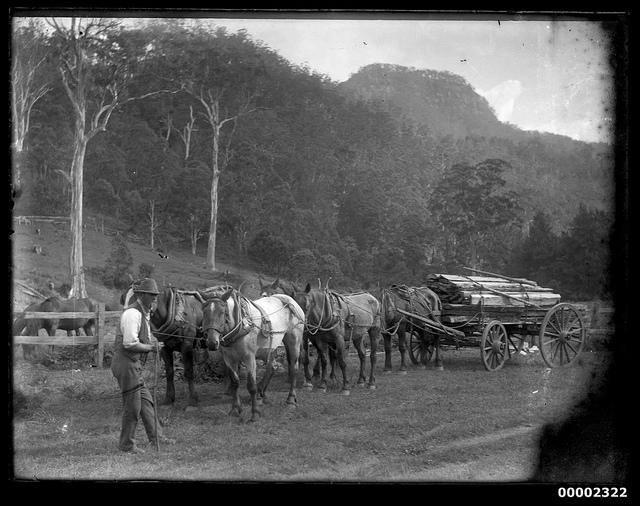What is the horse pulling?
Concise answer only. Wagon. What is the man hauling in the wagon?
Quick response, please. Logs. What is the man wearing over his shirt?
Answer briefly. Vest. What language is this photo captioned with?
Quick response, please. English. What is the team hauling?
Give a very brief answer. Wood. What is this man's profession?
Short answer required. Farmer. What are the numbers on the picture?
Short answer required. 00002322. Are those cattle or horses?
Quick response, please. Horses. How many wheels does the wagon have?
Concise answer only. 4. Does this look like a food wagon?
Answer briefly. No. What is this person pulling behind him?
Answer briefly. Horses. What material is the road made of?
Write a very short answer. Dirt. 